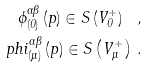Convert formula to latex. <formula><loc_0><loc_0><loc_500><loc_500>\phi _ { ( 0 ) } ^ { \alpha \beta } \left ( p \right ) \in S \left ( V _ { 0 } ^ { + } \right ) \ , \\ p h i _ { ( \mu ) } ^ { \alpha \beta } \left ( p \right ) \in S \left ( V _ { \mu } ^ { + } \right ) \, .</formula> 